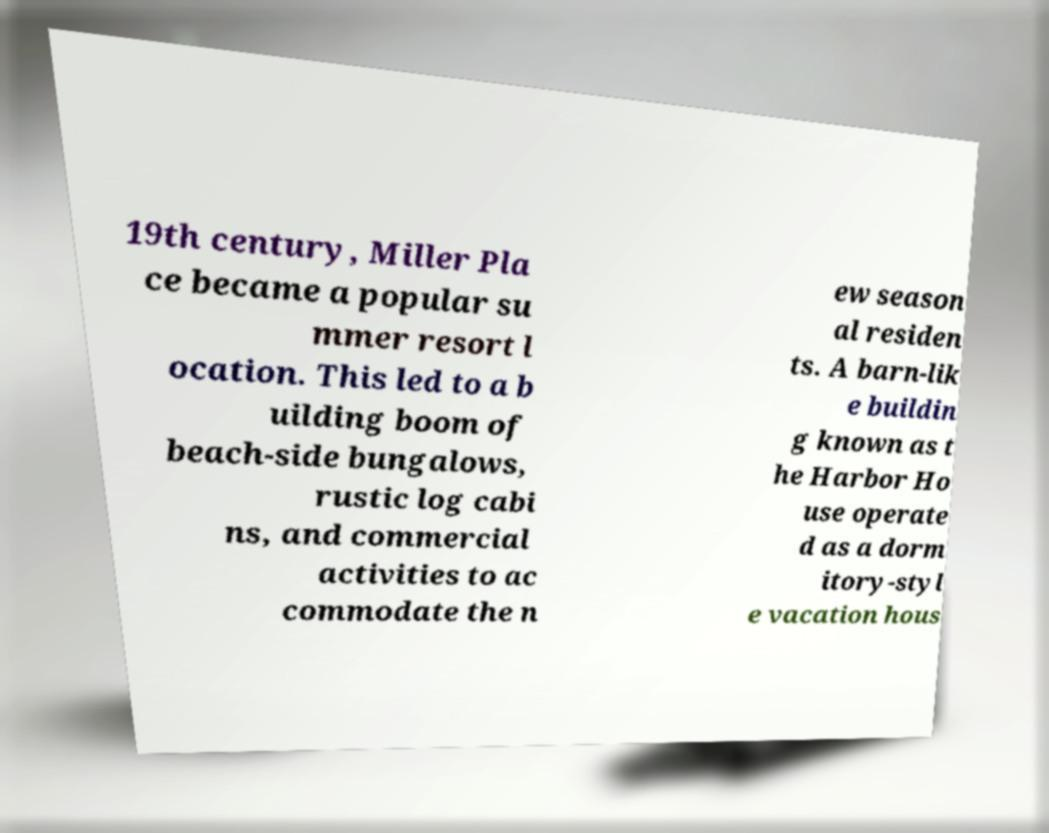For documentation purposes, I need the text within this image transcribed. Could you provide that? 19th century, Miller Pla ce became a popular su mmer resort l ocation. This led to a b uilding boom of beach-side bungalows, rustic log cabi ns, and commercial activities to ac commodate the n ew season al residen ts. A barn-lik e buildin g known as t he Harbor Ho use operate d as a dorm itory-styl e vacation hous 